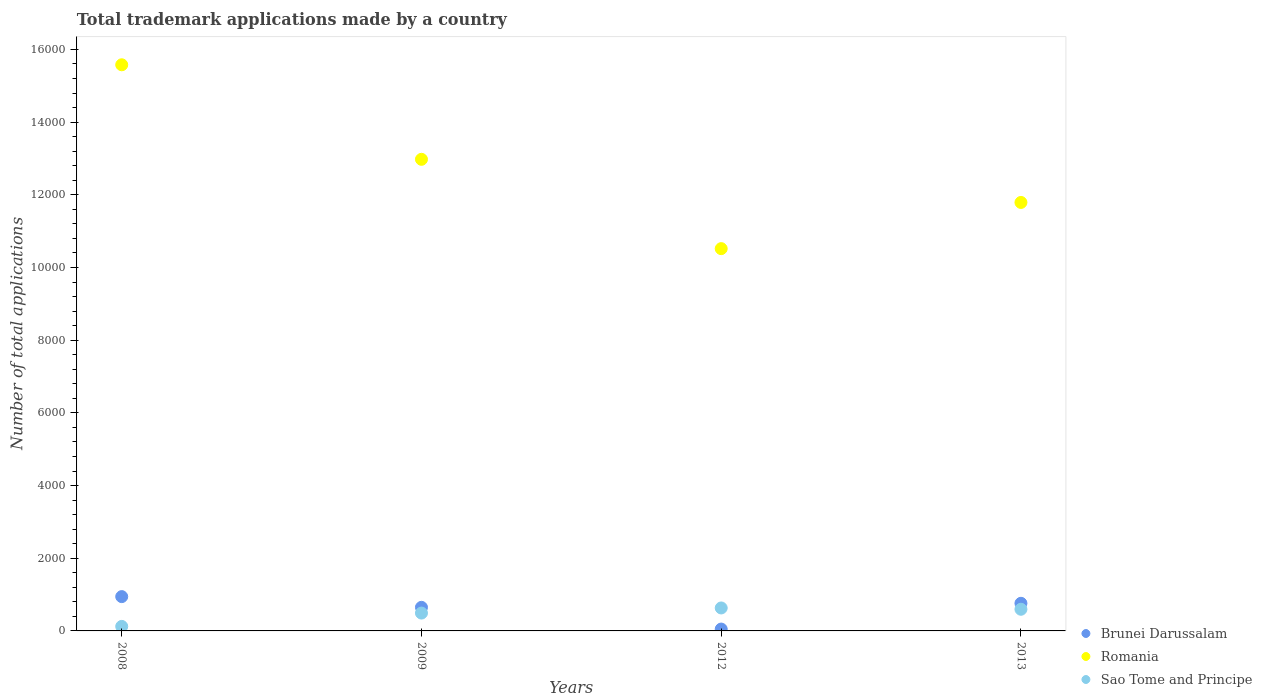Is the number of dotlines equal to the number of legend labels?
Offer a very short reply. Yes. What is the number of applications made by in Brunei Darussalam in 2008?
Your response must be concise. 944. Across all years, what is the maximum number of applications made by in Sao Tome and Principe?
Your answer should be very brief. 632. In which year was the number of applications made by in Romania minimum?
Your answer should be compact. 2012. What is the total number of applications made by in Romania in the graph?
Give a very brief answer. 5.09e+04. What is the difference between the number of applications made by in Sao Tome and Principe in 2009 and that in 2012?
Offer a terse response. -141. What is the difference between the number of applications made by in Sao Tome and Principe in 2009 and the number of applications made by in Brunei Darussalam in 2012?
Your answer should be compact. 440. What is the average number of applications made by in Sao Tome and Principe per year?
Give a very brief answer. 460.75. In the year 2013, what is the difference between the number of applications made by in Romania and number of applications made by in Brunei Darussalam?
Make the answer very short. 1.10e+04. What is the ratio of the number of applications made by in Brunei Darussalam in 2008 to that in 2009?
Keep it short and to the point. 1.45. Is the difference between the number of applications made by in Romania in 2009 and 2013 greater than the difference between the number of applications made by in Brunei Darussalam in 2009 and 2013?
Offer a terse response. Yes. What is the difference between the highest and the lowest number of applications made by in Sao Tome and Principe?
Provide a short and direct response. 508. Is it the case that in every year, the sum of the number of applications made by in Sao Tome and Principe and number of applications made by in Romania  is greater than the number of applications made by in Brunei Darussalam?
Your response must be concise. Yes. Is the number of applications made by in Sao Tome and Principe strictly greater than the number of applications made by in Romania over the years?
Your answer should be very brief. No. How many years are there in the graph?
Keep it short and to the point. 4. What is the difference between two consecutive major ticks on the Y-axis?
Provide a succinct answer. 2000. Does the graph contain grids?
Offer a very short reply. No. Where does the legend appear in the graph?
Give a very brief answer. Bottom right. How are the legend labels stacked?
Offer a terse response. Vertical. What is the title of the graph?
Your answer should be very brief. Total trademark applications made by a country. Does "Maldives" appear as one of the legend labels in the graph?
Your response must be concise. No. What is the label or title of the X-axis?
Provide a short and direct response. Years. What is the label or title of the Y-axis?
Offer a terse response. Number of total applications. What is the Number of total applications of Brunei Darussalam in 2008?
Your response must be concise. 944. What is the Number of total applications in Romania in 2008?
Offer a terse response. 1.56e+04. What is the Number of total applications of Sao Tome and Principe in 2008?
Provide a succinct answer. 124. What is the Number of total applications in Brunei Darussalam in 2009?
Provide a succinct answer. 649. What is the Number of total applications of Romania in 2009?
Provide a short and direct response. 1.30e+04. What is the Number of total applications in Sao Tome and Principe in 2009?
Provide a short and direct response. 491. What is the Number of total applications of Romania in 2012?
Provide a short and direct response. 1.05e+04. What is the Number of total applications of Sao Tome and Principe in 2012?
Provide a short and direct response. 632. What is the Number of total applications of Brunei Darussalam in 2013?
Provide a succinct answer. 760. What is the Number of total applications in Romania in 2013?
Ensure brevity in your answer.  1.18e+04. What is the Number of total applications in Sao Tome and Principe in 2013?
Provide a succinct answer. 596. Across all years, what is the maximum Number of total applications of Brunei Darussalam?
Offer a very short reply. 944. Across all years, what is the maximum Number of total applications in Romania?
Offer a terse response. 1.56e+04. Across all years, what is the maximum Number of total applications of Sao Tome and Principe?
Your answer should be compact. 632. Across all years, what is the minimum Number of total applications of Romania?
Make the answer very short. 1.05e+04. Across all years, what is the minimum Number of total applications of Sao Tome and Principe?
Keep it short and to the point. 124. What is the total Number of total applications of Brunei Darussalam in the graph?
Your answer should be very brief. 2404. What is the total Number of total applications in Romania in the graph?
Provide a short and direct response. 5.09e+04. What is the total Number of total applications of Sao Tome and Principe in the graph?
Your answer should be compact. 1843. What is the difference between the Number of total applications of Brunei Darussalam in 2008 and that in 2009?
Your answer should be compact. 295. What is the difference between the Number of total applications of Romania in 2008 and that in 2009?
Provide a succinct answer. 2601. What is the difference between the Number of total applications in Sao Tome and Principe in 2008 and that in 2009?
Ensure brevity in your answer.  -367. What is the difference between the Number of total applications of Brunei Darussalam in 2008 and that in 2012?
Provide a short and direct response. 893. What is the difference between the Number of total applications of Romania in 2008 and that in 2012?
Offer a terse response. 5059. What is the difference between the Number of total applications in Sao Tome and Principe in 2008 and that in 2012?
Keep it short and to the point. -508. What is the difference between the Number of total applications in Brunei Darussalam in 2008 and that in 2013?
Provide a succinct answer. 184. What is the difference between the Number of total applications in Romania in 2008 and that in 2013?
Offer a terse response. 3788. What is the difference between the Number of total applications of Sao Tome and Principe in 2008 and that in 2013?
Ensure brevity in your answer.  -472. What is the difference between the Number of total applications of Brunei Darussalam in 2009 and that in 2012?
Your answer should be compact. 598. What is the difference between the Number of total applications of Romania in 2009 and that in 2012?
Provide a succinct answer. 2458. What is the difference between the Number of total applications in Sao Tome and Principe in 2009 and that in 2012?
Keep it short and to the point. -141. What is the difference between the Number of total applications in Brunei Darussalam in 2009 and that in 2013?
Offer a terse response. -111. What is the difference between the Number of total applications of Romania in 2009 and that in 2013?
Provide a short and direct response. 1187. What is the difference between the Number of total applications of Sao Tome and Principe in 2009 and that in 2013?
Your answer should be very brief. -105. What is the difference between the Number of total applications in Brunei Darussalam in 2012 and that in 2013?
Your answer should be very brief. -709. What is the difference between the Number of total applications in Romania in 2012 and that in 2013?
Your answer should be very brief. -1271. What is the difference between the Number of total applications in Sao Tome and Principe in 2012 and that in 2013?
Your answer should be very brief. 36. What is the difference between the Number of total applications of Brunei Darussalam in 2008 and the Number of total applications of Romania in 2009?
Your answer should be very brief. -1.20e+04. What is the difference between the Number of total applications in Brunei Darussalam in 2008 and the Number of total applications in Sao Tome and Principe in 2009?
Your answer should be very brief. 453. What is the difference between the Number of total applications in Romania in 2008 and the Number of total applications in Sao Tome and Principe in 2009?
Provide a succinct answer. 1.51e+04. What is the difference between the Number of total applications in Brunei Darussalam in 2008 and the Number of total applications in Romania in 2012?
Ensure brevity in your answer.  -9575. What is the difference between the Number of total applications of Brunei Darussalam in 2008 and the Number of total applications of Sao Tome and Principe in 2012?
Give a very brief answer. 312. What is the difference between the Number of total applications of Romania in 2008 and the Number of total applications of Sao Tome and Principe in 2012?
Offer a very short reply. 1.49e+04. What is the difference between the Number of total applications in Brunei Darussalam in 2008 and the Number of total applications in Romania in 2013?
Offer a very short reply. -1.08e+04. What is the difference between the Number of total applications in Brunei Darussalam in 2008 and the Number of total applications in Sao Tome and Principe in 2013?
Ensure brevity in your answer.  348. What is the difference between the Number of total applications in Romania in 2008 and the Number of total applications in Sao Tome and Principe in 2013?
Your answer should be compact. 1.50e+04. What is the difference between the Number of total applications of Brunei Darussalam in 2009 and the Number of total applications of Romania in 2012?
Offer a terse response. -9870. What is the difference between the Number of total applications in Romania in 2009 and the Number of total applications in Sao Tome and Principe in 2012?
Your answer should be very brief. 1.23e+04. What is the difference between the Number of total applications of Brunei Darussalam in 2009 and the Number of total applications of Romania in 2013?
Provide a short and direct response. -1.11e+04. What is the difference between the Number of total applications in Brunei Darussalam in 2009 and the Number of total applications in Sao Tome and Principe in 2013?
Give a very brief answer. 53. What is the difference between the Number of total applications of Romania in 2009 and the Number of total applications of Sao Tome and Principe in 2013?
Provide a succinct answer. 1.24e+04. What is the difference between the Number of total applications in Brunei Darussalam in 2012 and the Number of total applications in Romania in 2013?
Ensure brevity in your answer.  -1.17e+04. What is the difference between the Number of total applications in Brunei Darussalam in 2012 and the Number of total applications in Sao Tome and Principe in 2013?
Ensure brevity in your answer.  -545. What is the difference between the Number of total applications in Romania in 2012 and the Number of total applications in Sao Tome and Principe in 2013?
Make the answer very short. 9923. What is the average Number of total applications in Brunei Darussalam per year?
Your response must be concise. 601. What is the average Number of total applications in Romania per year?
Offer a very short reply. 1.27e+04. What is the average Number of total applications of Sao Tome and Principe per year?
Keep it short and to the point. 460.75. In the year 2008, what is the difference between the Number of total applications of Brunei Darussalam and Number of total applications of Romania?
Provide a succinct answer. -1.46e+04. In the year 2008, what is the difference between the Number of total applications of Brunei Darussalam and Number of total applications of Sao Tome and Principe?
Ensure brevity in your answer.  820. In the year 2008, what is the difference between the Number of total applications in Romania and Number of total applications in Sao Tome and Principe?
Keep it short and to the point. 1.55e+04. In the year 2009, what is the difference between the Number of total applications in Brunei Darussalam and Number of total applications in Romania?
Your answer should be compact. -1.23e+04. In the year 2009, what is the difference between the Number of total applications in Brunei Darussalam and Number of total applications in Sao Tome and Principe?
Your answer should be very brief. 158. In the year 2009, what is the difference between the Number of total applications of Romania and Number of total applications of Sao Tome and Principe?
Make the answer very short. 1.25e+04. In the year 2012, what is the difference between the Number of total applications of Brunei Darussalam and Number of total applications of Romania?
Ensure brevity in your answer.  -1.05e+04. In the year 2012, what is the difference between the Number of total applications of Brunei Darussalam and Number of total applications of Sao Tome and Principe?
Your answer should be very brief. -581. In the year 2012, what is the difference between the Number of total applications of Romania and Number of total applications of Sao Tome and Principe?
Make the answer very short. 9887. In the year 2013, what is the difference between the Number of total applications in Brunei Darussalam and Number of total applications in Romania?
Your response must be concise. -1.10e+04. In the year 2013, what is the difference between the Number of total applications of Brunei Darussalam and Number of total applications of Sao Tome and Principe?
Make the answer very short. 164. In the year 2013, what is the difference between the Number of total applications of Romania and Number of total applications of Sao Tome and Principe?
Offer a terse response. 1.12e+04. What is the ratio of the Number of total applications of Brunei Darussalam in 2008 to that in 2009?
Your response must be concise. 1.45. What is the ratio of the Number of total applications in Romania in 2008 to that in 2009?
Ensure brevity in your answer.  1.2. What is the ratio of the Number of total applications of Sao Tome and Principe in 2008 to that in 2009?
Provide a short and direct response. 0.25. What is the ratio of the Number of total applications of Brunei Darussalam in 2008 to that in 2012?
Provide a short and direct response. 18.51. What is the ratio of the Number of total applications of Romania in 2008 to that in 2012?
Make the answer very short. 1.48. What is the ratio of the Number of total applications in Sao Tome and Principe in 2008 to that in 2012?
Your answer should be compact. 0.2. What is the ratio of the Number of total applications in Brunei Darussalam in 2008 to that in 2013?
Your response must be concise. 1.24. What is the ratio of the Number of total applications in Romania in 2008 to that in 2013?
Give a very brief answer. 1.32. What is the ratio of the Number of total applications of Sao Tome and Principe in 2008 to that in 2013?
Offer a terse response. 0.21. What is the ratio of the Number of total applications in Brunei Darussalam in 2009 to that in 2012?
Your answer should be very brief. 12.73. What is the ratio of the Number of total applications of Romania in 2009 to that in 2012?
Give a very brief answer. 1.23. What is the ratio of the Number of total applications of Sao Tome and Principe in 2009 to that in 2012?
Your answer should be very brief. 0.78. What is the ratio of the Number of total applications in Brunei Darussalam in 2009 to that in 2013?
Keep it short and to the point. 0.85. What is the ratio of the Number of total applications in Romania in 2009 to that in 2013?
Your answer should be compact. 1.1. What is the ratio of the Number of total applications in Sao Tome and Principe in 2009 to that in 2013?
Ensure brevity in your answer.  0.82. What is the ratio of the Number of total applications in Brunei Darussalam in 2012 to that in 2013?
Ensure brevity in your answer.  0.07. What is the ratio of the Number of total applications of Romania in 2012 to that in 2013?
Ensure brevity in your answer.  0.89. What is the ratio of the Number of total applications in Sao Tome and Principe in 2012 to that in 2013?
Your answer should be very brief. 1.06. What is the difference between the highest and the second highest Number of total applications in Brunei Darussalam?
Your response must be concise. 184. What is the difference between the highest and the second highest Number of total applications of Romania?
Your answer should be compact. 2601. What is the difference between the highest and the second highest Number of total applications of Sao Tome and Principe?
Give a very brief answer. 36. What is the difference between the highest and the lowest Number of total applications in Brunei Darussalam?
Provide a succinct answer. 893. What is the difference between the highest and the lowest Number of total applications in Romania?
Offer a terse response. 5059. What is the difference between the highest and the lowest Number of total applications in Sao Tome and Principe?
Provide a short and direct response. 508. 